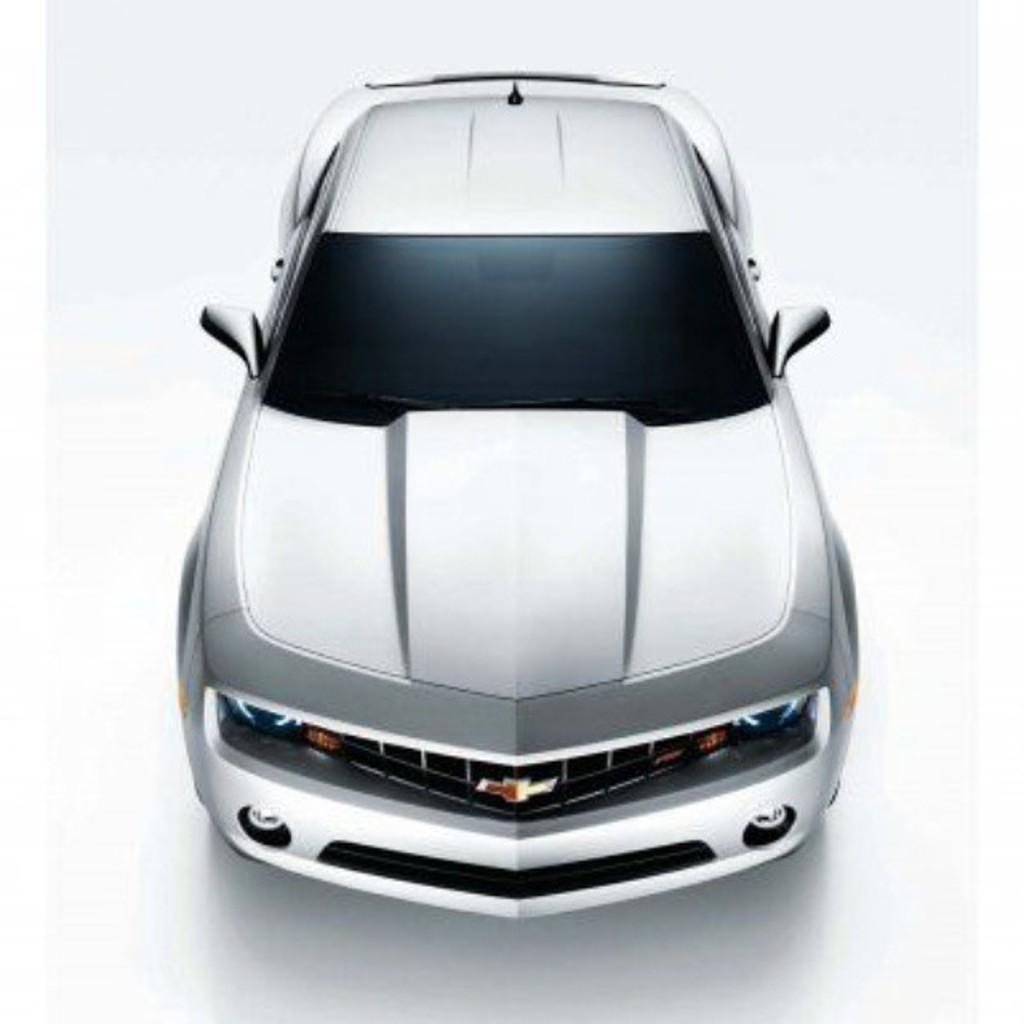Can you describe this image briefly? In this image there is a car on the surface which is in white color. 